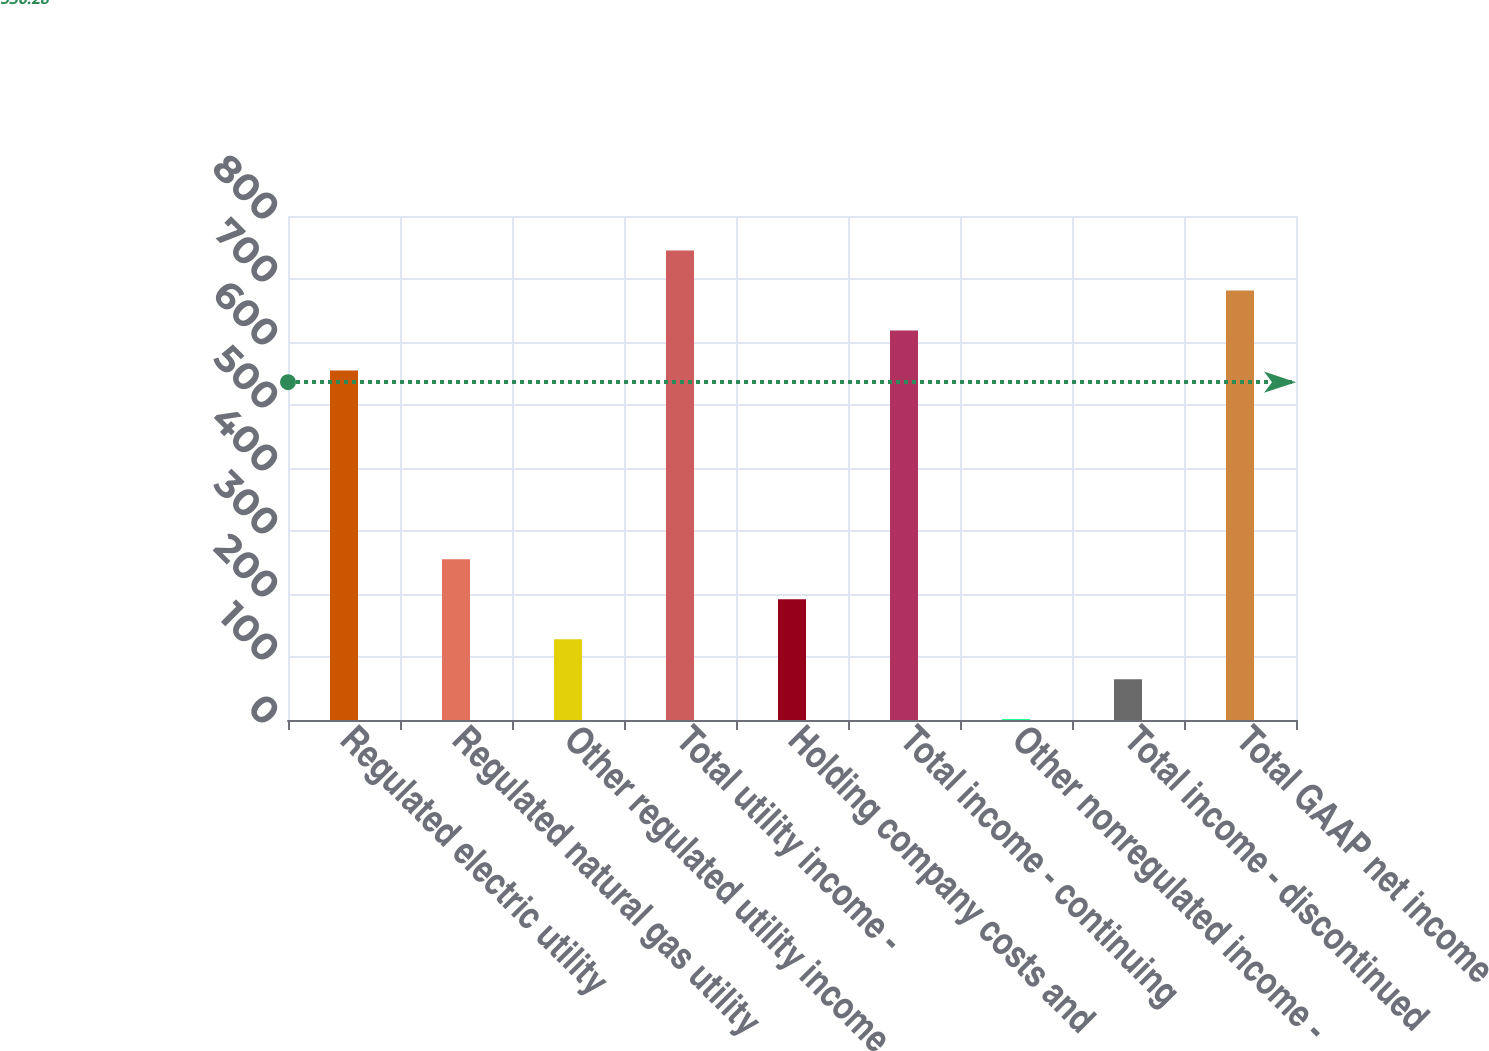Convert chart. <chart><loc_0><loc_0><loc_500><loc_500><bar_chart><fcel>Regulated electric utility<fcel>Regulated natural gas utility<fcel>Other regulated utility income<fcel>Total utility income -<fcel>Holding company costs and<fcel>Total income - continuing<fcel>Other nonregulated income -<fcel>Total income - discontinued<fcel>Total GAAP net income<nl><fcel>554.7<fcel>255.24<fcel>128.32<fcel>745.08<fcel>191.78<fcel>618.16<fcel>1.4<fcel>64.86<fcel>681.62<nl></chart> 